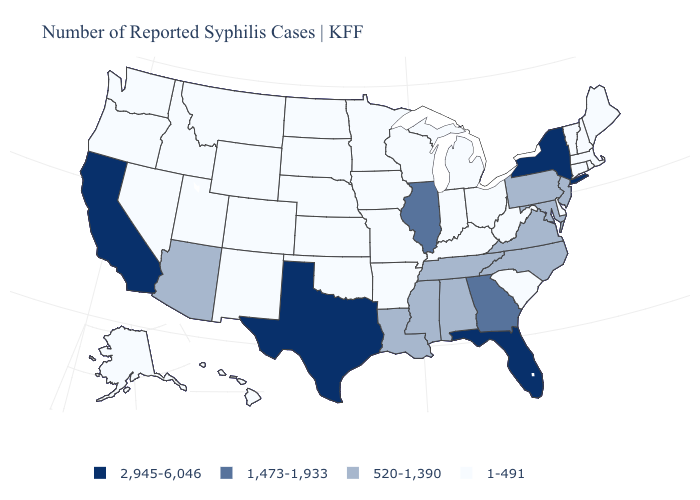Name the states that have a value in the range 520-1,390?
Be succinct. Alabama, Arizona, Louisiana, Maryland, Mississippi, New Jersey, North Carolina, Pennsylvania, Tennessee, Virginia. How many symbols are there in the legend?
Answer briefly. 4. What is the lowest value in the Northeast?
Concise answer only. 1-491. Name the states that have a value in the range 520-1,390?
Short answer required. Alabama, Arizona, Louisiana, Maryland, Mississippi, New Jersey, North Carolina, Pennsylvania, Tennessee, Virginia. Name the states that have a value in the range 520-1,390?
Give a very brief answer. Alabama, Arizona, Louisiana, Maryland, Mississippi, New Jersey, North Carolina, Pennsylvania, Tennessee, Virginia. Which states have the lowest value in the USA?
Quick response, please. Alaska, Arkansas, Colorado, Connecticut, Delaware, Hawaii, Idaho, Indiana, Iowa, Kansas, Kentucky, Maine, Massachusetts, Michigan, Minnesota, Missouri, Montana, Nebraska, Nevada, New Hampshire, New Mexico, North Dakota, Ohio, Oklahoma, Oregon, Rhode Island, South Carolina, South Dakota, Utah, Vermont, Washington, West Virginia, Wisconsin, Wyoming. What is the lowest value in the USA?
Be succinct. 1-491. Among the states that border New Mexico , which have the lowest value?
Short answer required. Colorado, Oklahoma, Utah. Does the first symbol in the legend represent the smallest category?
Be succinct. No. Among the states that border Arizona , which have the lowest value?
Answer briefly. Colorado, Nevada, New Mexico, Utah. What is the lowest value in states that border Connecticut?
Answer briefly. 1-491. Name the states that have a value in the range 2,945-6,046?
Be succinct. California, Florida, New York, Texas. What is the value of South Carolina?
Write a very short answer. 1-491. What is the value of Colorado?
Give a very brief answer. 1-491. Among the states that border Kentucky , does Tennessee have the highest value?
Quick response, please. No. 